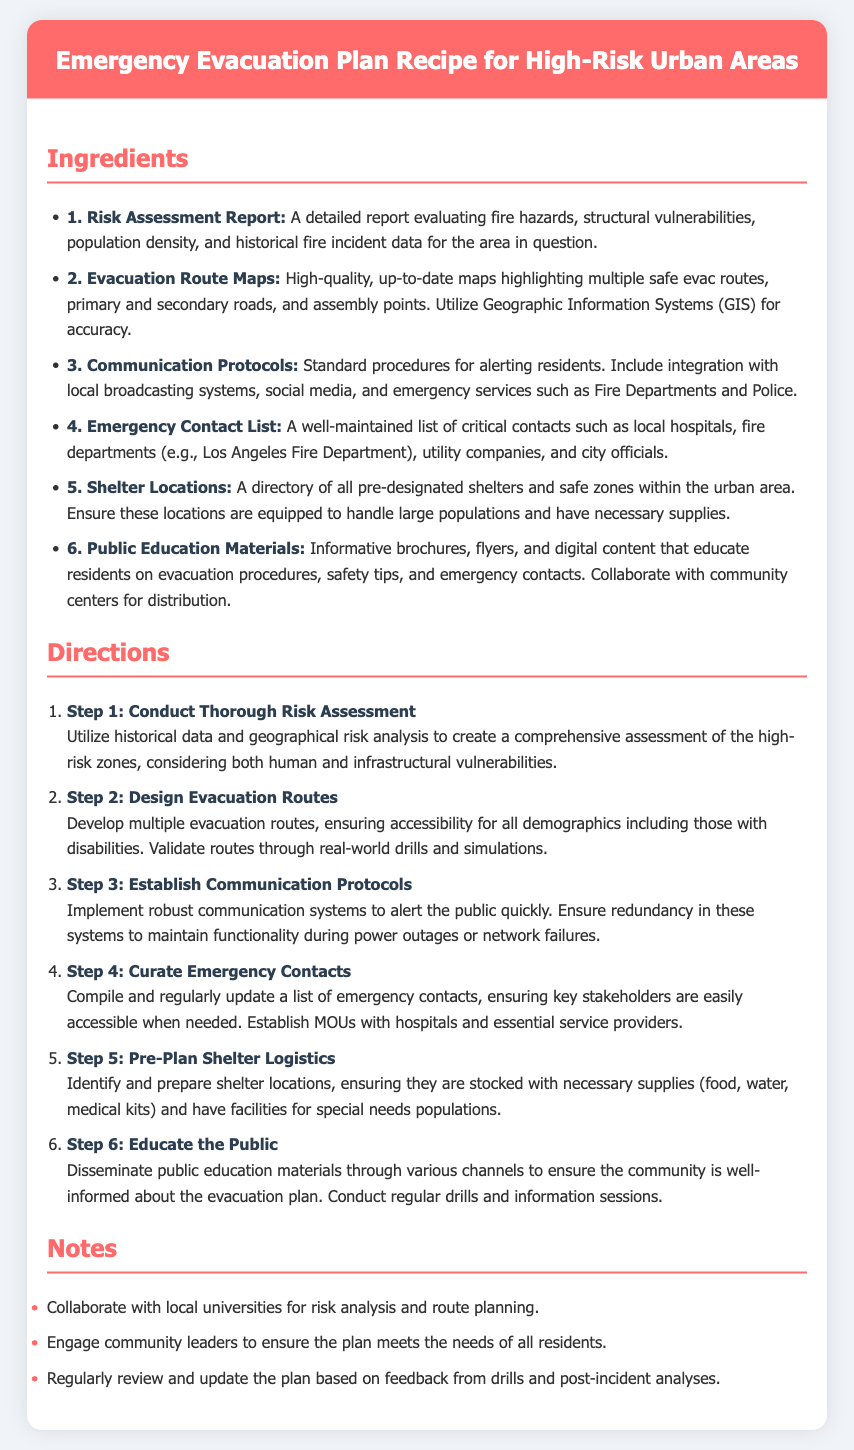What is the title of the document? The title of the document is specified in the header section of the recipe card.
Answer: Emergency Evacuation Plan Recipe for High-Risk Urban Areas How many steps are there in the directions? The directions section lists the steps involved in creating the evacuation plan, which are enumerated from 1 to 6.
Answer: 6 What is the first ingredient listed? The ingredients section starts with the first item required in the evacuation plan, which is detailed in the list.
Answer: Risk Assessment Report Which emergency service is mentioned in the Emergency Contact List? The Emergency Contact List includes specific services that should be contacted, and one of those services is highlighted.
Answer: Fire departments What does Step 2 focus on? Step 2 is specifically about developing aspects that are critical to evacuation during an emergency, highlighting the connection to route planning.
Answer: Design Evacuation Routes What type of materials is mentioned for public education? The document specifies types of resources to educate the public about safety and emergency responses in the evacuation plan, which can be categorized as informative.
Answer: Public Education Materials What color is used for the recipe header? The design of the recipe card includes a specific color for the header section, which is described in the style section.
Answer: #ff6b6b Name one suggestion provided in the notes section. The notes section offers additional advice or guidance, which can be actionable for enhancing the plan's effectiveness.
Answer: Engage community leaders to ensure the plan meets the needs of all residents 